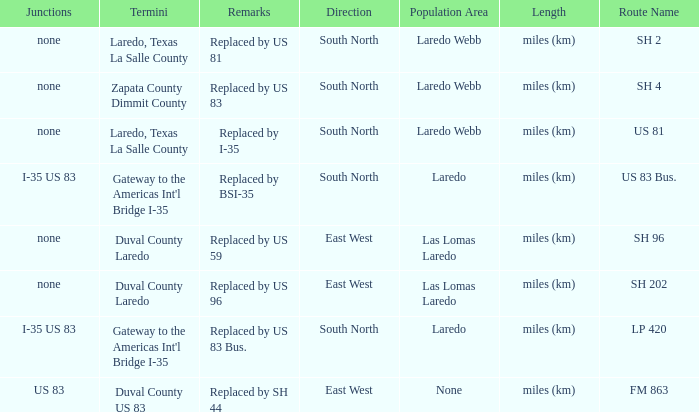Can you parse all the data within this table? {'header': ['Junctions', 'Termini', 'Remarks', 'Direction', 'Population Area', 'Length', 'Route Name'], 'rows': [['none', 'Laredo, Texas La Salle County', 'Replaced by US 81', 'South North', 'Laredo Webb', 'miles (km)', 'SH 2'], ['none', 'Zapata County Dimmit County', 'Replaced by US 83', 'South North', 'Laredo Webb', 'miles (km)', 'SH 4'], ['none', 'Laredo, Texas La Salle County', 'Replaced by I-35', 'South North', 'Laredo Webb', 'miles (km)', 'US 81'], ['I-35 US 83', "Gateway to the Americas Int'l Bridge I-35", 'Replaced by BSI-35', 'South North', 'Laredo', 'miles (km)', 'US 83 Bus.'], ['none', 'Duval County Laredo', 'Replaced by US 59', 'East West', 'Las Lomas Laredo', 'miles (km)', 'SH 96'], ['none', 'Duval County Laredo', 'Replaced by US 96', 'East West', 'Las Lomas Laredo', 'miles (km)', 'SH 202'], ['I-35 US 83', "Gateway to the Americas Int'l Bridge I-35", 'Replaced by US 83 Bus.', 'South North', 'Laredo', 'miles (km)', 'LP 420'], ['US 83', 'Duval County US 83', 'Replaced by SH 44', 'East West', 'None', 'miles (km)', 'FM 863']]} Which population areas have "replaced by us 83" listed in their remarks section? Laredo Webb. 